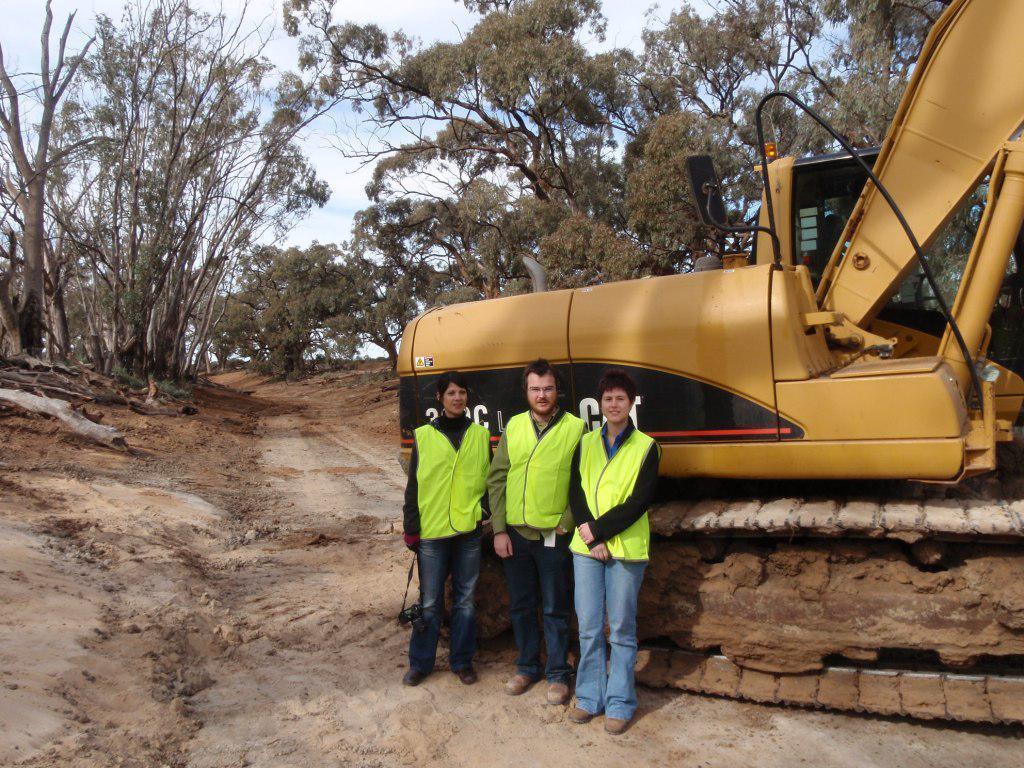In one or two sentences, can you explain what this image depicts? In this image we can see people standing on the ground and a bulldozer is placed at the backside of them. In the background we can see trees, logs on the ground and sky with clouds. 